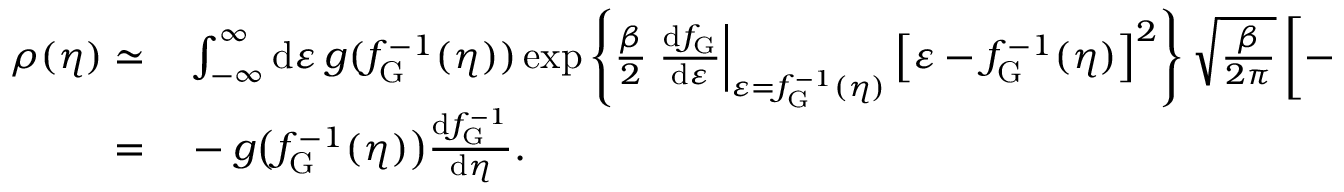Convert formula to latex. <formula><loc_0><loc_0><loc_500><loc_500>\begin{array} { r l } { \rho ( \eta ) \simeq } & \int _ { - \infty } ^ { \infty } d \varepsilon \, g ( f _ { G } ^ { - 1 } ( \eta ) ) \exp \left \{ \frac { \beta } { 2 } \frac { d f _ { G } } { d \varepsilon } \right | _ { \varepsilon = f _ { G } ^ { - 1 } ( \eta ) } \left [ \varepsilon - f _ { G } ^ { - 1 } ( \eta ) \right ] ^ { 2 } \right \} \sqrt { \frac { \beta } { 2 \pi } } \left [ - \frac { d f _ { G } ^ { - 1 } } { d \eta } \right ] ^ { 1 / 2 } } \\ { = } & - g \left ( f _ { G } ^ { - 1 } ( \eta ) \right ) \frac { d f _ { G } ^ { - 1 } } { d \eta } . } \end{array}</formula> 